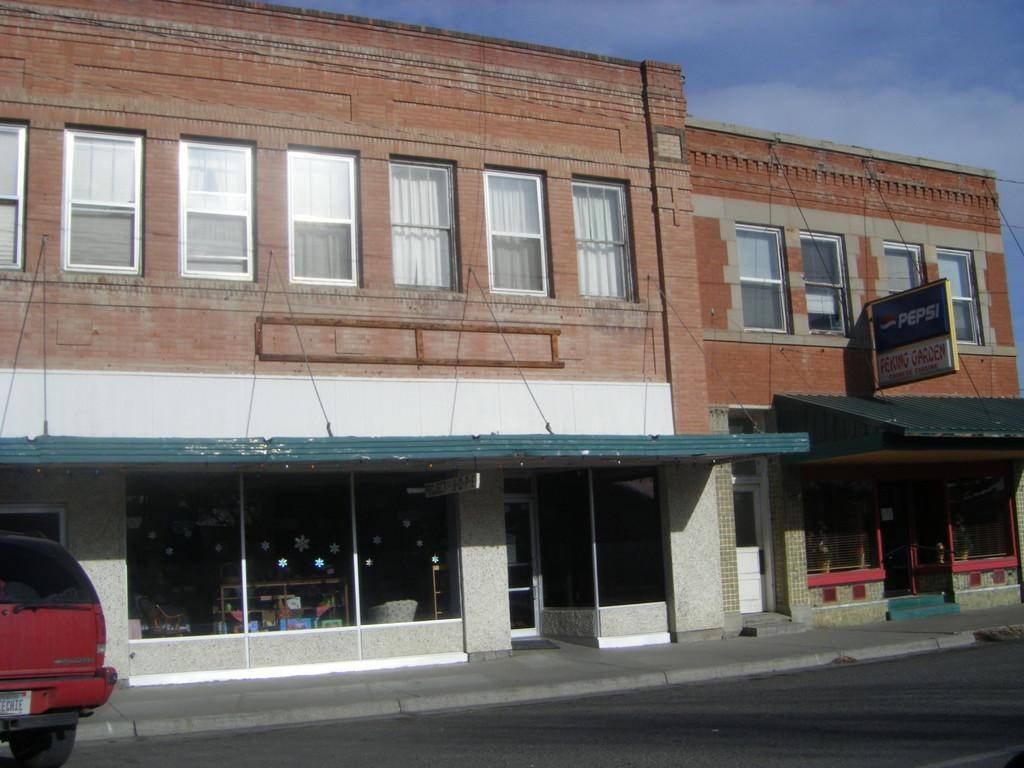What is on the road in the image? There is a vehicle on the road in the image. What structures can be seen in the image? There are buildings in the image. What object is present in the image that might have information or a message? There is a board in the image. What architectural feature is visible in the image? There are windows in the image. What can be seen in the background of the image? The sky with clouds is visible in the background of the image. Can you tell me how many times the vehicle kicks the cannon in the image? There is no cannon present in the image, and vehicles do not kick objects. What type of boundary can be seen in the image? There is no boundary present in the image; the focus is on the vehicle, buildings, board, windows, and sky. 